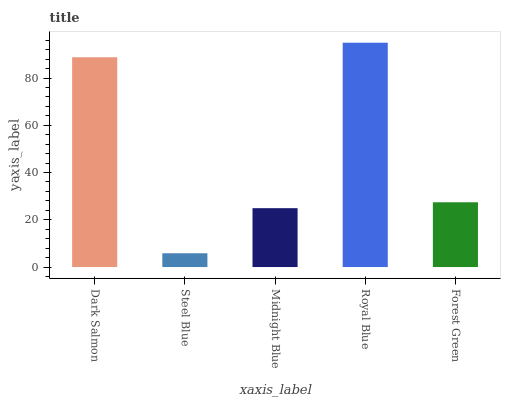Is Steel Blue the minimum?
Answer yes or no. Yes. Is Royal Blue the maximum?
Answer yes or no. Yes. Is Midnight Blue the minimum?
Answer yes or no. No. Is Midnight Blue the maximum?
Answer yes or no. No. Is Midnight Blue greater than Steel Blue?
Answer yes or no. Yes. Is Steel Blue less than Midnight Blue?
Answer yes or no. Yes. Is Steel Blue greater than Midnight Blue?
Answer yes or no. No. Is Midnight Blue less than Steel Blue?
Answer yes or no. No. Is Forest Green the high median?
Answer yes or no. Yes. Is Forest Green the low median?
Answer yes or no. Yes. Is Royal Blue the high median?
Answer yes or no. No. Is Midnight Blue the low median?
Answer yes or no. No. 